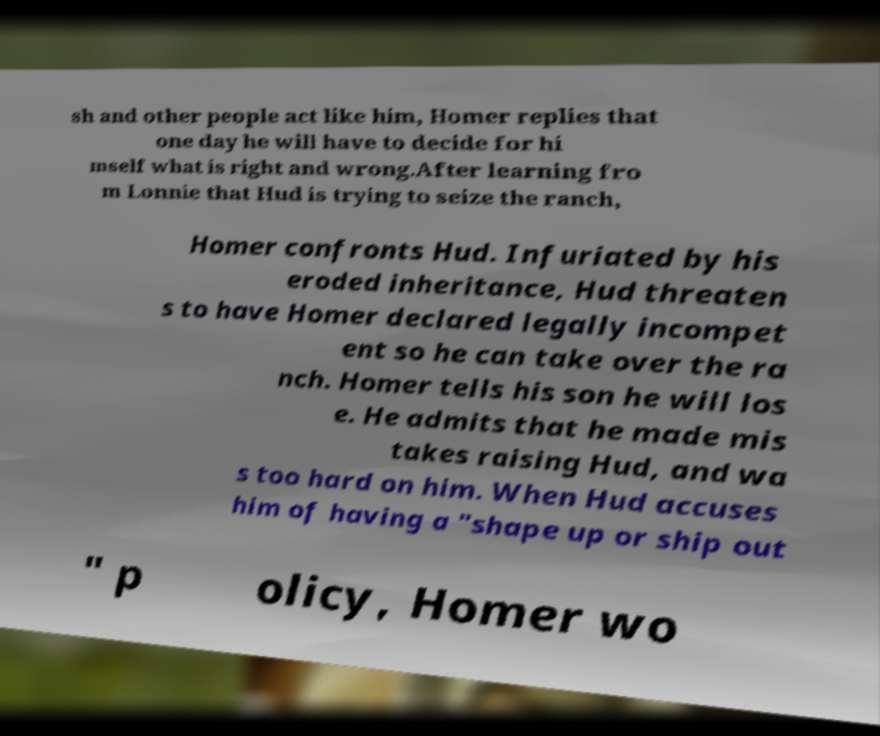Can you accurately transcribe the text from the provided image for me? sh and other people act like him, Homer replies that one day he will have to decide for hi mself what is right and wrong.After learning fro m Lonnie that Hud is trying to seize the ranch, Homer confronts Hud. Infuriated by his eroded inheritance, Hud threaten s to have Homer declared legally incompet ent so he can take over the ra nch. Homer tells his son he will los e. He admits that he made mis takes raising Hud, and wa s too hard on him. When Hud accuses him of having a "shape up or ship out " p olicy, Homer wo 